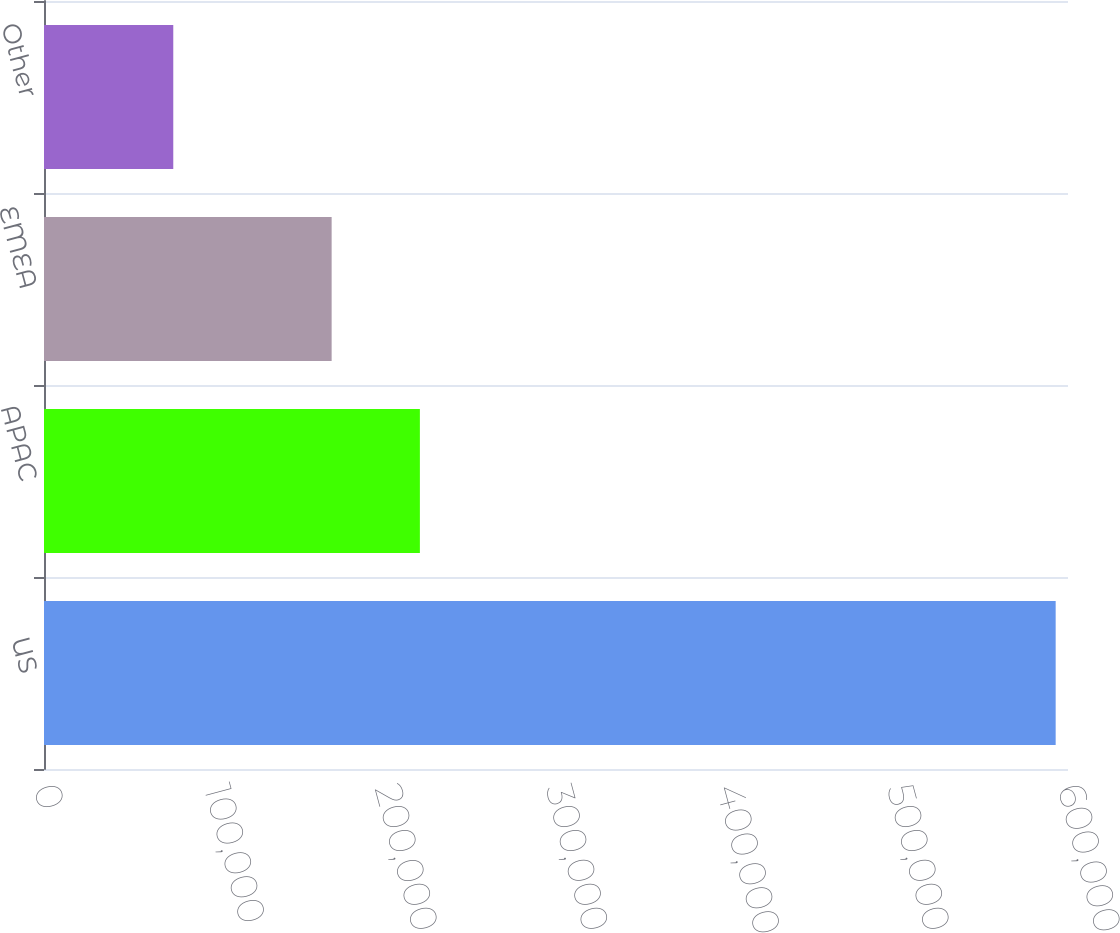Convert chart to OTSL. <chart><loc_0><loc_0><loc_500><loc_500><bar_chart><fcel>US<fcel>APAC<fcel>EMEA<fcel>Other<nl><fcel>592774<fcel>220243<fcel>168540<fcel>75745<nl></chart> 